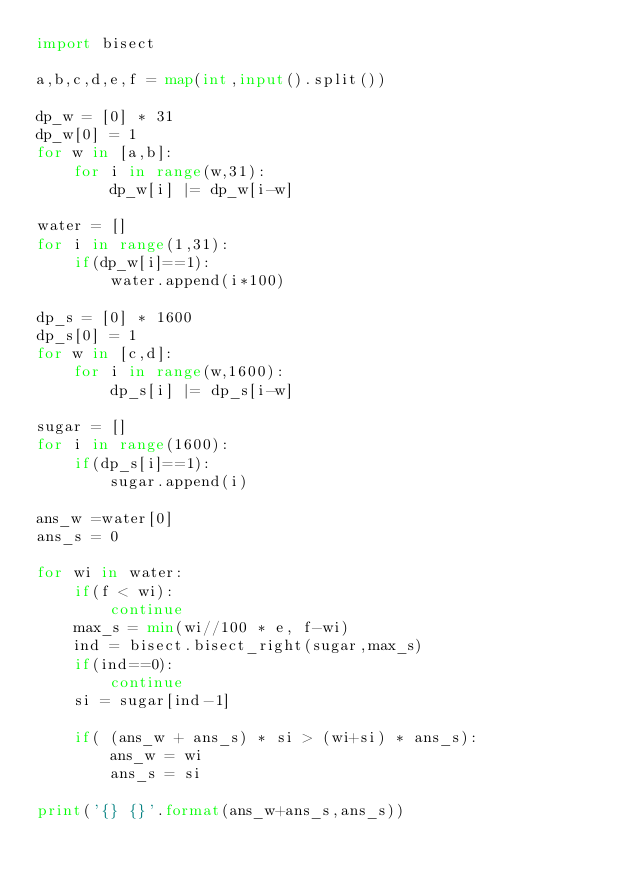<code> <loc_0><loc_0><loc_500><loc_500><_Python_>import bisect

a,b,c,d,e,f = map(int,input().split())

dp_w = [0] * 31
dp_w[0] = 1
for w in [a,b]:
    for i in range(w,31):
        dp_w[i] |= dp_w[i-w]

water = []
for i in range(1,31):
    if(dp_w[i]==1):
        water.append(i*100)

dp_s = [0] * 1600
dp_s[0] = 1
for w in [c,d]:
    for i in range(w,1600):
        dp_s[i] |= dp_s[i-w]

sugar = []
for i in range(1600):
    if(dp_s[i]==1):
        sugar.append(i)

ans_w =water[0]
ans_s = 0

for wi in water:
    if(f < wi):
        continue
    max_s = min(wi//100 * e, f-wi)
    ind = bisect.bisect_right(sugar,max_s)
    if(ind==0):
        continue
    si = sugar[ind-1]

    if( (ans_w + ans_s) * si > (wi+si) * ans_s):
        ans_w = wi
        ans_s = si

print('{} {}'.format(ans_w+ans_s,ans_s))</code> 